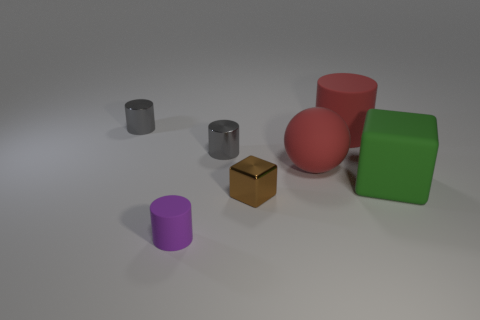Subtract all red blocks. How many gray cylinders are left? 2 Subtract all red cylinders. How many cylinders are left? 3 Subtract all large red cylinders. How many cylinders are left? 3 Subtract 2 cylinders. How many cylinders are left? 2 Add 2 tiny rubber objects. How many objects exist? 9 Subtract all green cylinders. Subtract all blue cubes. How many cylinders are left? 4 Subtract all cylinders. How many objects are left? 3 Subtract all gray matte cubes. Subtract all small brown things. How many objects are left? 6 Add 5 rubber blocks. How many rubber blocks are left? 6 Add 2 tiny yellow matte objects. How many tiny yellow matte objects exist? 2 